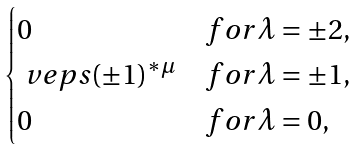<formula> <loc_0><loc_0><loc_500><loc_500>\begin{cases} 0 & f o r \lambda = \pm 2 , \\ \ v e p s ( \pm 1 ) ^ { * \mu } & f o r \lambda = \pm 1 , \\ 0 & f o r \lambda = 0 , \end{cases}</formula> 